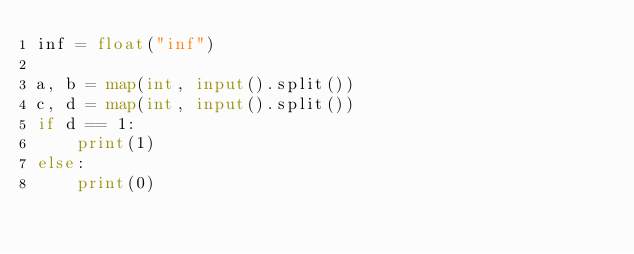<code> <loc_0><loc_0><loc_500><loc_500><_Python_>inf = float("inf")

a, b = map(int, input().split())
c, d = map(int, input().split())
if d == 1:
    print(1)
else:
    print(0)
</code> 